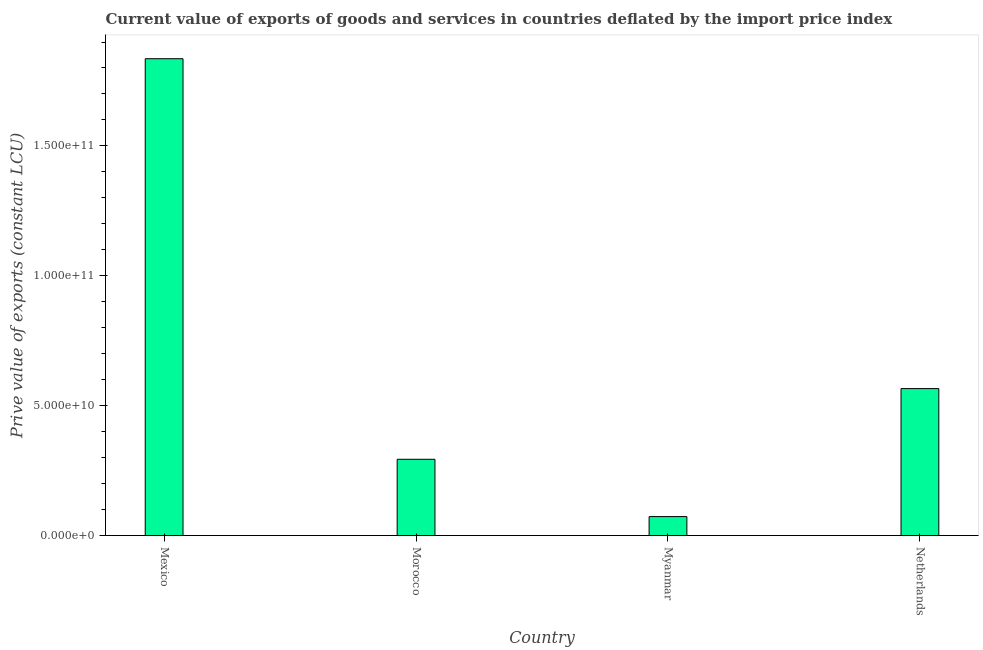Does the graph contain grids?
Your answer should be very brief. No. What is the title of the graph?
Offer a terse response. Current value of exports of goods and services in countries deflated by the import price index. What is the label or title of the Y-axis?
Offer a terse response. Prive value of exports (constant LCU). What is the price value of exports in Morocco?
Your response must be concise. 2.94e+1. Across all countries, what is the maximum price value of exports?
Keep it short and to the point. 1.84e+11. Across all countries, what is the minimum price value of exports?
Keep it short and to the point. 7.31e+09. In which country was the price value of exports minimum?
Your answer should be very brief. Myanmar. What is the sum of the price value of exports?
Ensure brevity in your answer.  2.77e+11. What is the difference between the price value of exports in Mexico and Myanmar?
Your answer should be compact. 1.76e+11. What is the average price value of exports per country?
Ensure brevity in your answer.  6.92e+1. What is the median price value of exports?
Your answer should be compact. 4.30e+1. What is the ratio of the price value of exports in Mexico to that in Myanmar?
Ensure brevity in your answer.  25.13. Is the price value of exports in Mexico less than that in Morocco?
Offer a very short reply. No. Is the difference between the price value of exports in Mexico and Morocco greater than the difference between any two countries?
Provide a short and direct response. No. What is the difference between the highest and the second highest price value of exports?
Your answer should be very brief. 1.27e+11. Is the sum of the price value of exports in Morocco and Myanmar greater than the maximum price value of exports across all countries?
Ensure brevity in your answer.  No. What is the difference between the highest and the lowest price value of exports?
Provide a short and direct response. 1.76e+11. How many bars are there?
Your answer should be very brief. 4. Are all the bars in the graph horizontal?
Keep it short and to the point. No. What is the difference between two consecutive major ticks on the Y-axis?
Provide a succinct answer. 5.00e+1. Are the values on the major ticks of Y-axis written in scientific E-notation?
Give a very brief answer. Yes. What is the Prive value of exports (constant LCU) in Mexico?
Your answer should be compact. 1.84e+11. What is the Prive value of exports (constant LCU) in Morocco?
Provide a succinct answer. 2.94e+1. What is the Prive value of exports (constant LCU) of Myanmar?
Offer a very short reply. 7.31e+09. What is the Prive value of exports (constant LCU) of Netherlands?
Your answer should be compact. 5.66e+1. What is the difference between the Prive value of exports (constant LCU) in Mexico and Morocco?
Your answer should be compact. 1.54e+11. What is the difference between the Prive value of exports (constant LCU) in Mexico and Myanmar?
Make the answer very short. 1.76e+11. What is the difference between the Prive value of exports (constant LCU) in Mexico and Netherlands?
Your answer should be very brief. 1.27e+11. What is the difference between the Prive value of exports (constant LCU) in Morocco and Myanmar?
Provide a short and direct response. 2.21e+1. What is the difference between the Prive value of exports (constant LCU) in Morocco and Netherlands?
Keep it short and to the point. -2.72e+1. What is the difference between the Prive value of exports (constant LCU) in Myanmar and Netherlands?
Make the answer very short. -4.93e+1. What is the ratio of the Prive value of exports (constant LCU) in Mexico to that in Morocco?
Provide a succinct answer. 6.25. What is the ratio of the Prive value of exports (constant LCU) in Mexico to that in Myanmar?
Ensure brevity in your answer.  25.13. What is the ratio of the Prive value of exports (constant LCU) in Mexico to that in Netherlands?
Offer a very short reply. 3.24. What is the ratio of the Prive value of exports (constant LCU) in Morocco to that in Myanmar?
Keep it short and to the point. 4.02. What is the ratio of the Prive value of exports (constant LCU) in Morocco to that in Netherlands?
Provide a succinct answer. 0.52. What is the ratio of the Prive value of exports (constant LCU) in Myanmar to that in Netherlands?
Provide a short and direct response. 0.13. 